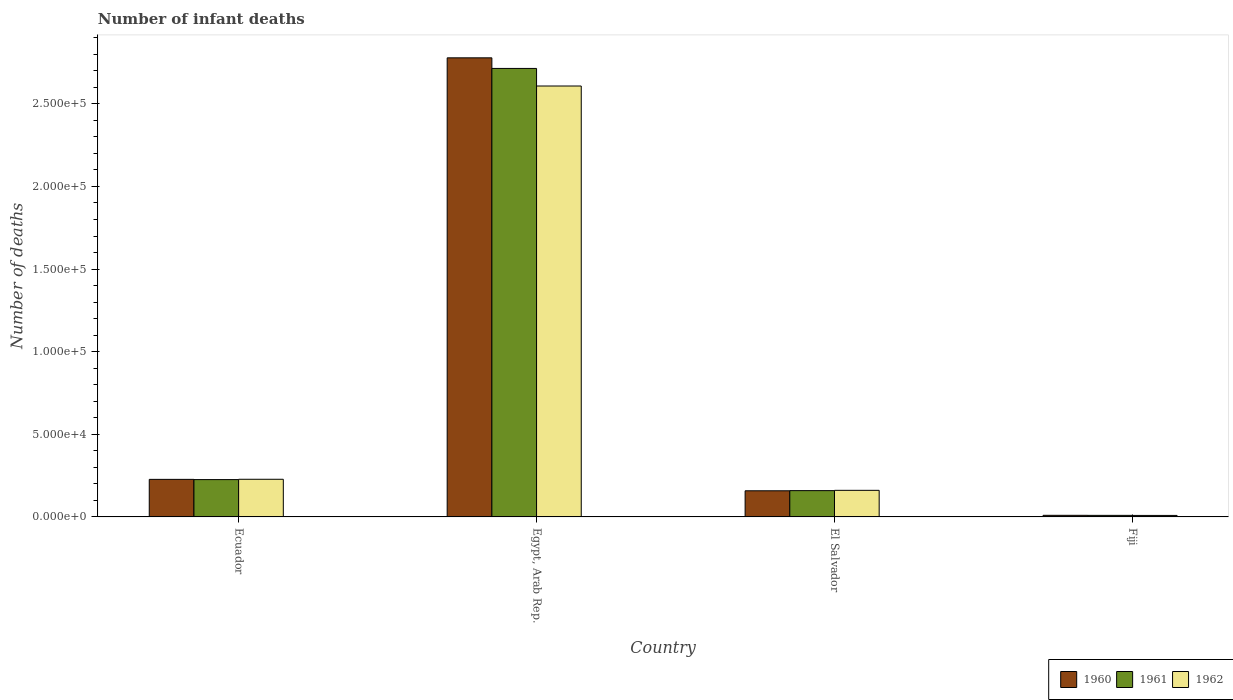How many groups of bars are there?
Your response must be concise. 4. What is the label of the 1st group of bars from the left?
Provide a succinct answer. Ecuador. What is the number of infant deaths in 1962 in Ecuador?
Your answer should be very brief. 2.28e+04. Across all countries, what is the maximum number of infant deaths in 1962?
Offer a very short reply. 2.61e+05. Across all countries, what is the minimum number of infant deaths in 1960?
Provide a succinct answer. 977. In which country was the number of infant deaths in 1960 maximum?
Make the answer very short. Egypt, Arab Rep. In which country was the number of infant deaths in 1962 minimum?
Your answer should be compact. Fiji. What is the total number of infant deaths in 1960 in the graph?
Offer a terse response. 3.17e+05. What is the difference between the number of infant deaths in 1961 in Egypt, Arab Rep. and that in Fiji?
Your answer should be compact. 2.70e+05. What is the difference between the number of infant deaths in 1961 in Fiji and the number of infant deaths in 1962 in Ecuador?
Your answer should be very brief. -2.18e+04. What is the average number of infant deaths in 1961 per country?
Provide a short and direct response. 7.77e+04. What is the difference between the number of infant deaths of/in 1962 and number of infant deaths of/in 1961 in El Salvador?
Ensure brevity in your answer.  174. What is the ratio of the number of infant deaths in 1960 in Ecuador to that in Fiji?
Provide a short and direct response. 23.27. Is the difference between the number of infant deaths in 1962 in Ecuador and Fiji greater than the difference between the number of infant deaths in 1961 in Ecuador and Fiji?
Offer a terse response. Yes. What is the difference between the highest and the second highest number of infant deaths in 1961?
Provide a succinct answer. 6672. What is the difference between the highest and the lowest number of infant deaths in 1962?
Keep it short and to the point. 2.60e+05. What does the 1st bar from the left in Ecuador represents?
Make the answer very short. 1960. What does the 3rd bar from the right in Egypt, Arab Rep. represents?
Your response must be concise. 1960. How many bars are there?
Your response must be concise. 12. What is the difference between two consecutive major ticks on the Y-axis?
Your answer should be very brief. 5.00e+04. Does the graph contain any zero values?
Your answer should be very brief. No. Where does the legend appear in the graph?
Keep it short and to the point. Bottom right. How many legend labels are there?
Offer a terse response. 3. How are the legend labels stacked?
Provide a succinct answer. Horizontal. What is the title of the graph?
Keep it short and to the point. Number of infant deaths. What is the label or title of the X-axis?
Your answer should be very brief. Country. What is the label or title of the Y-axis?
Give a very brief answer. Number of deaths. What is the Number of deaths of 1960 in Ecuador?
Provide a short and direct response. 2.27e+04. What is the Number of deaths of 1961 in Ecuador?
Ensure brevity in your answer.  2.26e+04. What is the Number of deaths in 1962 in Ecuador?
Provide a short and direct response. 2.28e+04. What is the Number of deaths in 1960 in Egypt, Arab Rep.?
Offer a very short reply. 2.78e+05. What is the Number of deaths in 1961 in Egypt, Arab Rep.?
Offer a terse response. 2.71e+05. What is the Number of deaths of 1962 in Egypt, Arab Rep.?
Provide a succinct answer. 2.61e+05. What is the Number of deaths in 1960 in El Salvador?
Your answer should be very brief. 1.58e+04. What is the Number of deaths in 1961 in El Salvador?
Give a very brief answer. 1.59e+04. What is the Number of deaths of 1962 in El Salvador?
Your answer should be very brief. 1.61e+04. What is the Number of deaths of 1960 in Fiji?
Make the answer very short. 977. What is the Number of deaths of 1961 in Fiji?
Ensure brevity in your answer.  945. What is the Number of deaths of 1962 in Fiji?
Your answer should be compact. 909. Across all countries, what is the maximum Number of deaths in 1960?
Your answer should be very brief. 2.78e+05. Across all countries, what is the maximum Number of deaths in 1961?
Keep it short and to the point. 2.71e+05. Across all countries, what is the maximum Number of deaths in 1962?
Offer a very short reply. 2.61e+05. Across all countries, what is the minimum Number of deaths in 1960?
Your answer should be compact. 977. Across all countries, what is the minimum Number of deaths of 1961?
Keep it short and to the point. 945. Across all countries, what is the minimum Number of deaths of 1962?
Ensure brevity in your answer.  909. What is the total Number of deaths of 1960 in the graph?
Your answer should be very brief. 3.17e+05. What is the total Number of deaths in 1961 in the graph?
Give a very brief answer. 3.11e+05. What is the total Number of deaths of 1962 in the graph?
Your answer should be compact. 3.01e+05. What is the difference between the Number of deaths of 1960 in Ecuador and that in Egypt, Arab Rep.?
Your answer should be very brief. -2.55e+05. What is the difference between the Number of deaths of 1961 in Ecuador and that in Egypt, Arab Rep.?
Offer a very short reply. -2.49e+05. What is the difference between the Number of deaths in 1962 in Ecuador and that in Egypt, Arab Rep.?
Offer a terse response. -2.38e+05. What is the difference between the Number of deaths of 1960 in Ecuador and that in El Salvador?
Your answer should be very brief. 6912. What is the difference between the Number of deaths in 1961 in Ecuador and that in El Salvador?
Offer a very short reply. 6672. What is the difference between the Number of deaths of 1962 in Ecuador and that in El Salvador?
Give a very brief answer. 6700. What is the difference between the Number of deaths of 1960 in Ecuador and that in Fiji?
Provide a succinct answer. 2.18e+04. What is the difference between the Number of deaths in 1961 in Ecuador and that in Fiji?
Make the answer very short. 2.16e+04. What is the difference between the Number of deaths of 1962 in Ecuador and that in Fiji?
Offer a very short reply. 2.19e+04. What is the difference between the Number of deaths in 1960 in Egypt, Arab Rep. and that in El Salvador?
Keep it short and to the point. 2.62e+05. What is the difference between the Number of deaths of 1961 in Egypt, Arab Rep. and that in El Salvador?
Ensure brevity in your answer.  2.56e+05. What is the difference between the Number of deaths in 1962 in Egypt, Arab Rep. and that in El Salvador?
Provide a succinct answer. 2.45e+05. What is the difference between the Number of deaths of 1960 in Egypt, Arab Rep. and that in Fiji?
Ensure brevity in your answer.  2.77e+05. What is the difference between the Number of deaths in 1961 in Egypt, Arab Rep. and that in Fiji?
Keep it short and to the point. 2.70e+05. What is the difference between the Number of deaths of 1962 in Egypt, Arab Rep. and that in Fiji?
Your answer should be compact. 2.60e+05. What is the difference between the Number of deaths of 1960 in El Salvador and that in Fiji?
Give a very brief answer. 1.48e+04. What is the difference between the Number of deaths in 1961 in El Salvador and that in Fiji?
Your response must be concise. 1.50e+04. What is the difference between the Number of deaths in 1962 in El Salvador and that in Fiji?
Provide a succinct answer. 1.52e+04. What is the difference between the Number of deaths in 1960 in Ecuador and the Number of deaths in 1961 in Egypt, Arab Rep.?
Make the answer very short. -2.49e+05. What is the difference between the Number of deaths in 1960 in Ecuador and the Number of deaths in 1962 in Egypt, Arab Rep.?
Give a very brief answer. -2.38e+05. What is the difference between the Number of deaths of 1961 in Ecuador and the Number of deaths of 1962 in Egypt, Arab Rep.?
Provide a short and direct response. -2.38e+05. What is the difference between the Number of deaths in 1960 in Ecuador and the Number of deaths in 1961 in El Salvador?
Keep it short and to the point. 6815. What is the difference between the Number of deaths of 1960 in Ecuador and the Number of deaths of 1962 in El Salvador?
Ensure brevity in your answer.  6641. What is the difference between the Number of deaths of 1961 in Ecuador and the Number of deaths of 1962 in El Salvador?
Make the answer very short. 6498. What is the difference between the Number of deaths in 1960 in Ecuador and the Number of deaths in 1961 in Fiji?
Your response must be concise. 2.18e+04. What is the difference between the Number of deaths of 1960 in Ecuador and the Number of deaths of 1962 in Fiji?
Your response must be concise. 2.18e+04. What is the difference between the Number of deaths of 1961 in Ecuador and the Number of deaths of 1962 in Fiji?
Keep it short and to the point. 2.17e+04. What is the difference between the Number of deaths in 1960 in Egypt, Arab Rep. and the Number of deaths in 1961 in El Salvador?
Your response must be concise. 2.62e+05. What is the difference between the Number of deaths in 1960 in Egypt, Arab Rep. and the Number of deaths in 1962 in El Salvador?
Make the answer very short. 2.62e+05. What is the difference between the Number of deaths of 1961 in Egypt, Arab Rep. and the Number of deaths of 1962 in El Salvador?
Offer a very short reply. 2.55e+05. What is the difference between the Number of deaths in 1960 in Egypt, Arab Rep. and the Number of deaths in 1961 in Fiji?
Offer a very short reply. 2.77e+05. What is the difference between the Number of deaths in 1960 in Egypt, Arab Rep. and the Number of deaths in 1962 in Fiji?
Keep it short and to the point. 2.77e+05. What is the difference between the Number of deaths in 1961 in Egypt, Arab Rep. and the Number of deaths in 1962 in Fiji?
Offer a very short reply. 2.71e+05. What is the difference between the Number of deaths of 1960 in El Salvador and the Number of deaths of 1961 in Fiji?
Give a very brief answer. 1.49e+04. What is the difference between the Number of deaths in 1960 in El Salvador and the Number of deaths in 1962 in Fiji?
Ensure brevity in your answer.  1.49e+04. What is the difference between the Number of deaths of 1961 in El Salvador and the Number of deaths of 1962 in Fiji?
Provide a succinct answer. 1.50e+04. What is the average Number of deaths of 1960 per country?
Provide a succinct answer. 7.93e+04. What is the average Number of deaths in 1961 per country?
Your answer should be very brief. 7.77e+04. What is the average Number of deaths in 1962 per country?
Provide a succinct answer. 7.51e+04. What is the difference between the Number of deaths in 1960 and Number of deaths in 1961 in Ecuador?
Provide a succinct answer. 143. What is the difference between the Number of deaths of 1960 and Number of deaths of 1962 in Ecuador?
Provide a short and direct response. -59. What is the difference between the Number of deaths of 1961 and Number of deaths of 1962 in Ecuador?
Your answer should be compact. -202. What is the difference between the Number of deaths of 1960 and Number of deaths of 1961 in Egypt, Arab Rep.?
Give a very brief answer. 6414. What is the difference between the Number of deaths in 1960 and Number of deaths in 1962 in Egypt, Arab Rep.?
Provide a succinct answer. 1.70e+04. What is the difference between the Number of deaths in 1961 and Number of deaths in 1962 in Egypt, Arab Rep.?
Ensure brevity in your answer.  1.06e+04. What is the difference between the Number of deaths of 1960 and Number of deaths of 1961 in El Salvador?
Offer a very short reply. -97. What is the difference between the Number of deaths in 1960 and Number of deaths in 1962 in El Salvador?
Keep it short and to the point. -271. What is the difference between the Number of deaths of 1961 and Number of deaths of 1962 in El Salvador?
Give a very brief answer. -174. What is the ratio of the Number of deaths of 1960 in Ecuador to that in Egypt, Arab Rep.?
Ensure brevity in your answer.  0.08. What is the ratio of the Number of deaths in 1961 in Ecuador to that in Egypt, Arab Rep.?
Keep it short and to the point. 0.08. What is the ratio of the Number of deaths of 1962 in Ecuador to that in Egypt, Arab Rep.?
Make the answer very short. 0.09. What is the ratio of the Number of deaths of 1960 in Ecuador to that in El Salvador?
Make the answer very short. 1.44. What is the ratio of the Number of deaths in 1961 in Ecuador to that in El Salvador?
Make the answer very short. 1.42. What is the ratio of the Number of deaths of 1962 in Ecuador to that in El Salvador?
Make the answer very short. 1.42. What is the ratio of the Number of deaths in 1960 in Ecuador to that in Fiji?
Your response must be concise. 23.27. What is the ratio of the Number of deaths of 1961 in Ecuador to that in Fiji?
Your answer should be very brief. 23.9. What is the ratio of the Number of deaths of 1962 in Ecuador to that in Fiji?
Provide a succinct answer. 25.07. What is the ratio of the Number of deaths of 1960 in Egypt, Arab Rep. to that in El Salvador?
Give a very brief answer. 17.56. What is the ratio of the Number of deaths in 1961 in Egypt, Arab Rep. to that in El Salvador?
Provide a short and direct response. 17.05. What is the ratio of the Number of deaths in 1962 in Egypt, Arab Rep. to that in El Salvador?
Keep it short and to the point. 16.21. What is the ratio of the Number of deaths of 1960 in Egypt, Arab Rep. to that in Fiji?
Offer a very short reply. 284.38. What is the ratio of the Number of deaths in 1961 in Egypt, Arab Rep. to that in Fiji?
Keep it short and to the point. 287.22. What is the ratio of the Number of deaths of 1962 in Egypt, Arab Rep. to that in Fiji?
Your answer should be compact. 286.9. What is the ratio of the Number of deaths of 1960 in El Salvador to that in Fiji?
Your answer should be very brief. 16.19. What is the ratio of the Number of deaths of 1961 in El Salvador to that in Fiji?
Provide a succinct answer. 16.84. What is the ratio of the Number of deaths of 1962 in El Salvador to that in Fiji?
Make the answer very short. 17.7. What is the difference between the highest and the second highest Number of deaths in 1960?
Give a very brief answer. 2.55e+05. What is the difference between the highest and the second highest Number of deaths of 1961?
Offer a terse response. 2.49e+05. What is the difference between the highest and the second highest Number of deaths in 1962?
Keep it short and to the point. 2.38e+05. What is the difference between the highest and the lowest Number of deaths in 1960?
Offer a very short reply. 2.77e+05. What is the difference between the highest and the lowest Number of deaths in 1961?
Provide a succinct answer. 2.70e+05. What is the difference between the highest and the lowest Number of deaths of 1962?
Ensure brevity in your answer.  2.60e+05. 